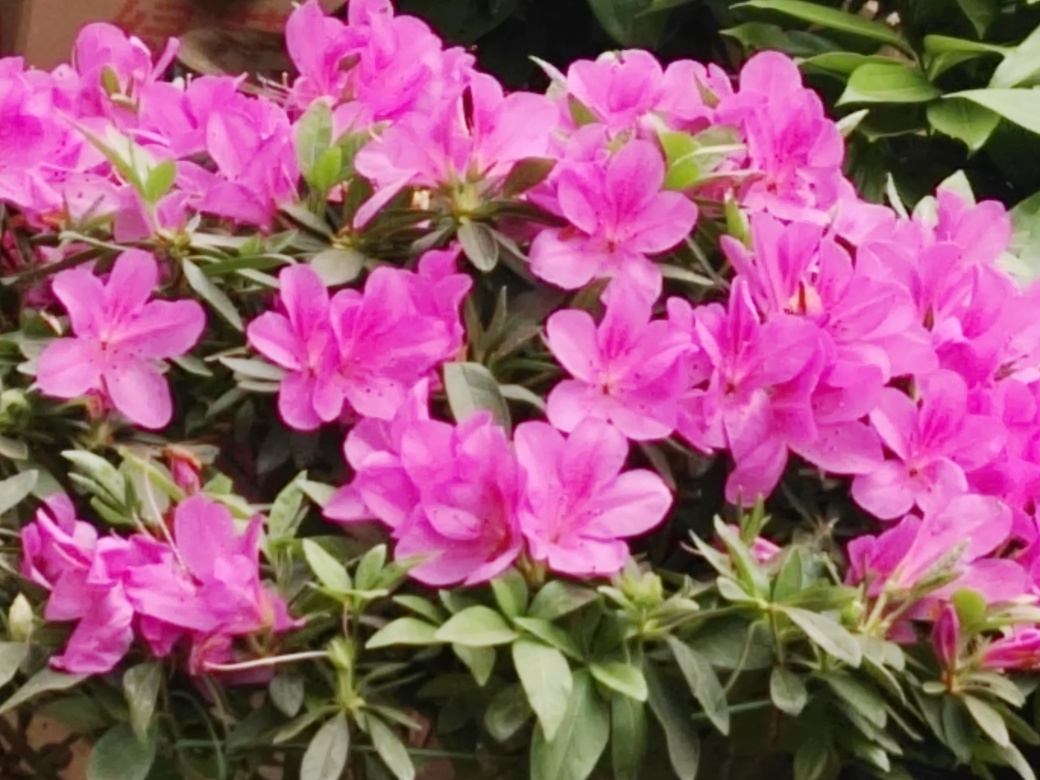What could be the significance of these flowers in a cultural context? Azaleas have a variety of cultural significances. In many cultures, they are symbols of femininity and softness due to their delicate flowers. They're often associated with abundance and beauty. In some East Asian cultures, azaleas are celebrated in festivals and signify the renewal of spring. They also are thought to represent temperance and restraint. 